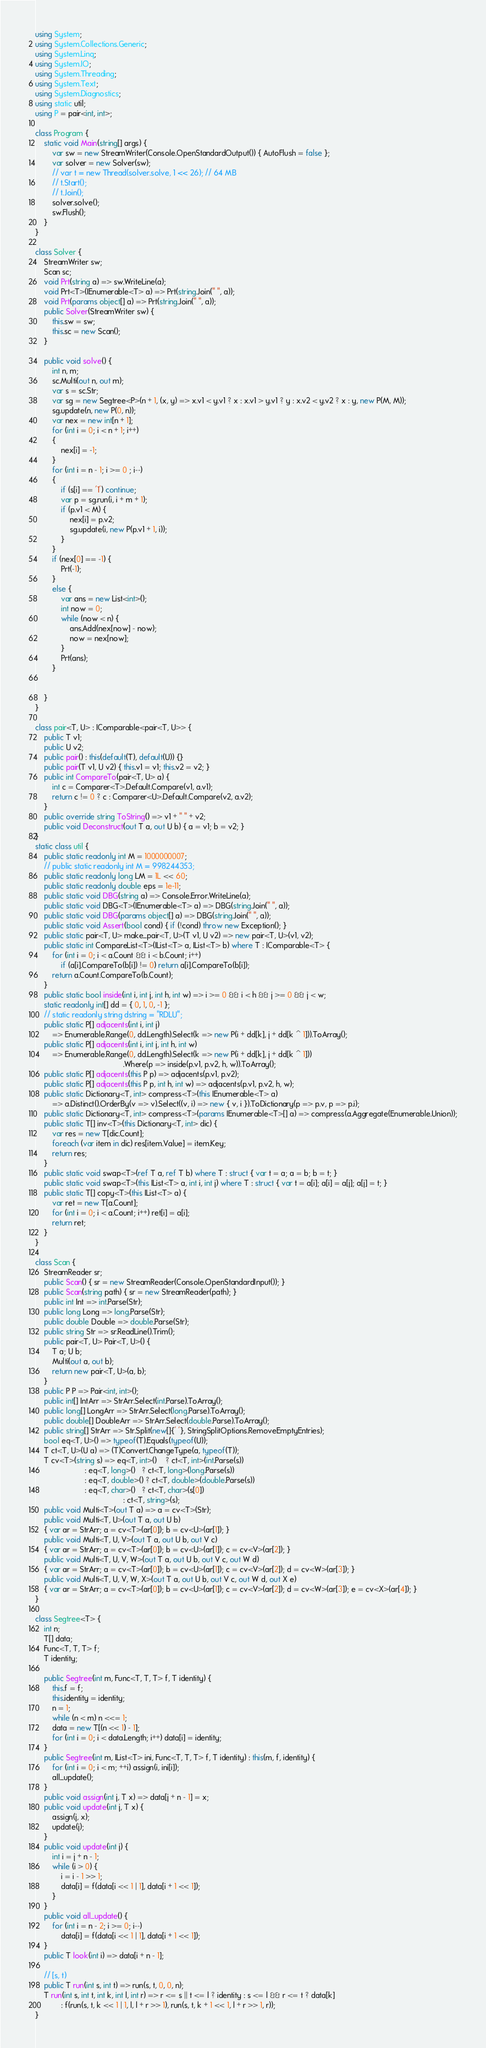Convert code to text. <code><loc_0><loc_0><loc_500><loc_500><_C#_>using System;
using System.Collections.Generic;
using System.Linq;
using System.IO;
using System.Threading;
using System.Text;
using System.Diagnostics;
using static util;
using P = pair<int, int>;

class Program {
    static void Main(string[] args) {
        var sw = new StreamWriter(Console.OpenStandardOutput()) { AutoFlush = false };
        var solver = new Solver(sw);
        // var t = new Thread(solver.solve, 1 << 26); // 64 MB
        // t.Start();
        // t.Join();
        solver.solve();
        sw.Flush();
    }
}

class Solver {
    StreamWriter sw;
    Scan sc;
    void Prt(string a) => sw.WriteLine(a);
    void Prt<T>(IEnumerable<T> a) => Prt(string.Join(" ", a));
    void Prt(params object[] a) => Prt(string.Join(" ", a));
    public Solver(StreamWriter sw) {
        this.sw = sw;
        this.sc = new Scan();
    }

    public void solve() {
        int n, m;
        sc.Multi(out n, out m);
        var s = sc.Str;
        var sg = new Segtree<P>(n + 1, (x, y) => x.v1 < y.v1 ? x : x.v1 > y.v1 ? y : x.v2 < y.v2 ? x : y, new P(M, M));
        sg.update(n, new P(0, n));
        var nex = new int[n + 1];
        for (int i = 0; i < n + 1; i++)
        {
            nex[i] = -1;
        }
        for (int i = n - 1; i >= 0 ; i--)
        {
            if (s[i] == '1') continue;
            var p = sg.run(i, i + m + 1);
            if (p.v1 < M) {
                nex[i] = p.v2;
                sg.update(i, new P(p.v1 + 1, i));
            }
        }
        if (nex[0] == -1) {
            Prt(-1);
        }
        else {
            var ans = new List<int>();
            int now = 0;
            while (now < n) {
                ans.Add(nex[now] - now);
                now = nex[now];
            }
            Prt(ans);
        }


    }
}

class pair<T, U> : IComparable<pair<T, U>> {
    public T v1;
    public U v2;
    public pair() : this(default(T), default(U)) {}
    public pair(T v1, U v2) { this.v1 = v1; this.v2 = v2; }
    public int CompareTo(pair<T, U> a) {
        int c = Comparer<T>.Default.Compare(v1, a.v1);
        return c != 0 ? c : Comparer<U>.Default.Compare(v2, a.v2);
    }
    public override string ToString() => v1 + " " + v2;
    public void Deconstruct(out T a, out U b) { a = v1; b = v2; }
}
static class util {
    public static readonly int M = 1000000007;
    // public static readonly int M = 998244353;
    public static readonly long LM = 1L << 60;
    public static readonly double eps = 1e-11;
    public static void DBG(string a) => Console.Error.WriteLine(a);
    public static void DBG<T>(IEnumerable<T> a) => DBG(string.Join(" ", a));
    public static void DBG(params object[] a) => DBG(string.Join(" ", a));
    public static void Assert(bool cond) { if (!cond) throw new Exception(); }
    public static pair<T, U> make_pair<T, U>(T v1, U v2) => new pair<T, U>(v1, v2);
    public static int CompareList<T>(IList<T> a, IList<T> b) where T : IComparable<T> {
        for (int i = 0; i < a.Count && i < b.Count; i++)
            if (a[i].CompareTo(b[i]) != 0) return a[i].CompareTo(b[i]);
        return a.Count.CompareTo(b.Count);
    }
    public static bool inside(int i, int j, int h, int w) => i >= 0 && i < h && j >= 0 && j < w;
    static readonly int[] dd = { 0, 1, 0, -1 };
    // static readonly string dstring = "RDLU";
    public static P[] adjacents(int i, int j)
        => Enumerable.Range(0, dd.Length).Select(k => new P(i + dd[k], j + dd[k ^ 1])).ToArray();
    public static P[] adjacents(int i, int j, int h, int w)
        => Enumerable.Range(0, dd.Length).Select(k => new P(i + dd[k], j + dd[k ^ 1]))
                                         .Where(p => inside(p.v1, p.v2, h, w)).ToArray();
    public static P[] adjacents(this P p) => adjacents(p.v1, p.v2);
    public static P[] adjacents(this P p, int h, int w) => adjacents(p.v1, p.v2, h, w);
    public static Dictionary<T, int> compress<T>(this IEnumerable<T> a)
        => a.Distinct().OrderBy(v => v).Select((v, i) => new { v, i }).ToDictionary(p => p.v, p => p.i);
    public static Dictionary<T, int> compress<T>(params IEnumerable<T>[] a) => compress(a.Aggregate(Enumerable.Union));
    public static T[] inv<T>(this Dictionary<T, int> dic) {
        var res = new T[dic.Count];
        foreach (var item in dic) res[item.Value] = item.Key;
        return res;
    }
    public static void swap<T>(ref T a, ref T b) where T : struct { var t = a; a = b; b = t; }
    public static void swap<T>(this IList<T> a, int i, int j) where T : struct { var t = a[i]; a[i] = a[j]; a[j] = t; }
    public static T[] copy<T>(this IList<T> a) {
        var ret = new T[a.Count];
        for (int i = 0; i < a.Count; i++) ret[i] = a[i];
        return ret;
    }
}

class Scan {
    StreamReader sr;
    public Scan() { sr = new StreamReader(Console.OpenStandardInput()); }
    public Scan(string path) { sr = new StreamReader(path); }
    public int Int => int.Parse(Str);
    public long Long => long.Parse(Str);
    public double Double => double.Parse(Str);
    public string Str => sr.ReadLine().Trim();
    public pair<T, U> Pair<T, U>() {
        T a; U b;
        Multi(out a, out b);
        return new pair<T, U>(a, b);
    }
    public P P => Pair<int, int>();
    public int[] IntArr => StrArr.Select(int.Parse).ToArray();
    public long[] LongArr => StrArr.Select(long.Parse).ToArray();
    public double[] DoubleArr => StrArr.Select(double.Parse).ToArray();
    public string[] StrArr => Str.Split(new[]{' '}, StringSplitOptions.RemoveEmptyEntries);
    bool eq<T, U>() => typeof(T).Equals(typeof(U));
    T ct<T, U>(U a) => (T)Convert.ChangeType(a, typeof(T));
    T cv<T>(string s) => eq<T, int>()    ? ct<T, int>(int.Parse(s))
                       : eq<T, long>()   ? ct<T, long>(long.Parse(s))
                       : eq<T, double>() ? ct<T, double>(double.Parse(s))
                       : eq<T, char>()   ? ct<T, char>(s[0])
                                         : ct<T, string>(s);
    public void Multi<T>(out T a) => a = cv<T>(Str);
    public void Multi<T, U>(out T a, out U b)
    { var ar = StrArr; a = cv<T>(ar[0]); b = cv<U>(ar[1]); }
    public void Multi<T, U, V>(out T a, out U b, out V c)
    { var ar = StrArr; a = cv<T>(ar[0]); b = cv<U>(ar[1]); c = cv<V>(ar[2]); }
    public void Multi<T, U, V, W>(out T a, out U b, out V c, out W d)
    { var ar = StrArr; a = cv<T>(ar[0]); b = cv<U>(ar[1]); c = cv<V>(ar[2]); d = cv<W>(ar[3]); }
    public void Multi<T, U, V, W, X>(out T a, out U b, out V c, out W d, out X e)
    { var ar = StrArr; a = cv<T>(ar[0]); b = cv<U>(ar[1]); c = cv<V>(ar[2]); d = cv<W>(ar[3]); e = cv<X>(ar[4]); }
}

class Segtree<T> {
    int n;
    T[] data;
    Func<T, T, T> f;
    T identity;

    public Segtree(int m, Func<T, T, T> f, T identity) {
        this.f = f;
        this.identity = identity;
        n = 1;
        while (n < m) n <<= 1;
        data = new T[(n << 1) - 1];
        for (int i = 0; i < data.Length; i++) data[i] = identity;
    }
    public Segtree(int m, IList<T> ini, Func<T, T, T> f, T identity) : this(m, f, identity) {
        for (int i = 0; i < m; ++i) assign(i, ini[i]);
        all_update();
    }
    public void assign(int j, T x) => data[j + n - 1] = x;
    public void update(int j, T x) {
        assign(j, x);
        update(j);
    }
    public void update(int j) {
        int i = j + n - 1;
        while (i > 0) {
            i = i - 1 >> 1;
            data[i] = f(data[i << 1 | 1], data[i + 1 << 1]);
        }
    }
    public void all_update() {
        for (int i = n - 2; i >= 0; i--)
            data[i] = f(data[i << 1 | 1], data[i + 1 << 1]);
    }
    public T look(int i) => data[i + n - 1];

    // [s, t)
    public T run(int s, int t) => run(s, t, 0, 0, n);
    T run(int s, int t, int k, int l, int r) => r <= s || t <= l ? identity : s <= l && r <= t ? data[k]
            : f(run(s, t, k << 1 | 1, l, l + r >> 1), run(s, t, k + 1 << 1, l + r >> 1, r));
}
</code> 